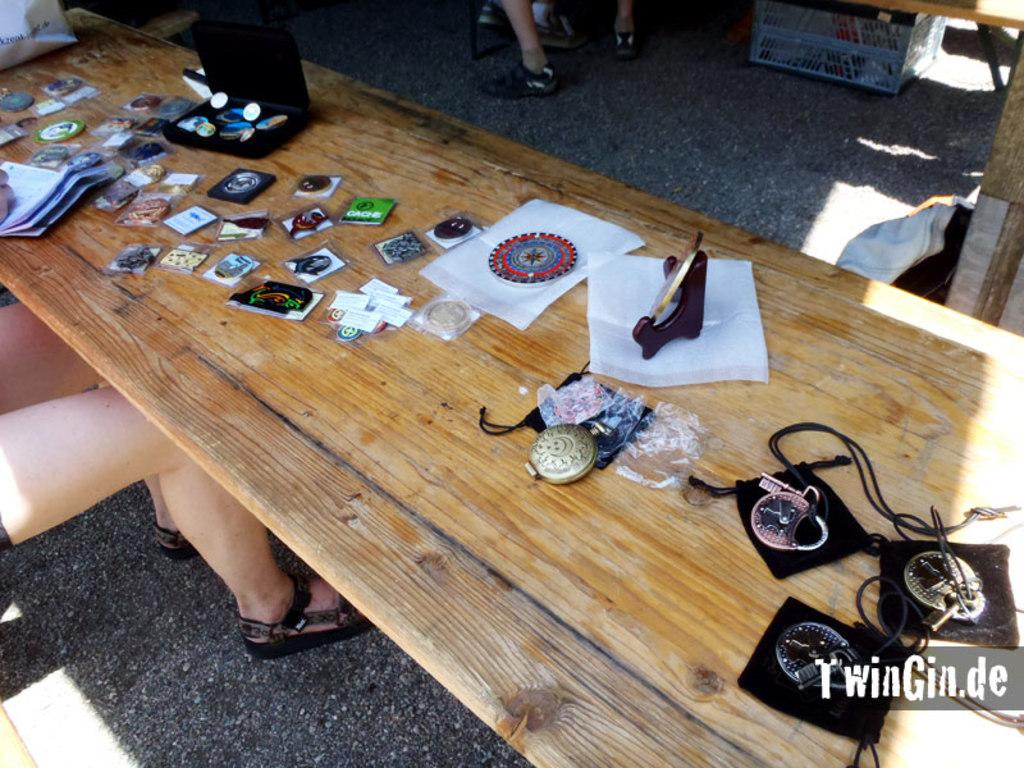What type of furniture is in the image? There is a wooden desk in the image. What is on the wooden desk? Objects are placed on the desk. Can you describe the people in the image? There is a woman sitting beside the desk and a person standing behind the desk. What type of club does the woman sitting beside the desk belong to? There is no information about a club in the image, so it cannot be determined. 